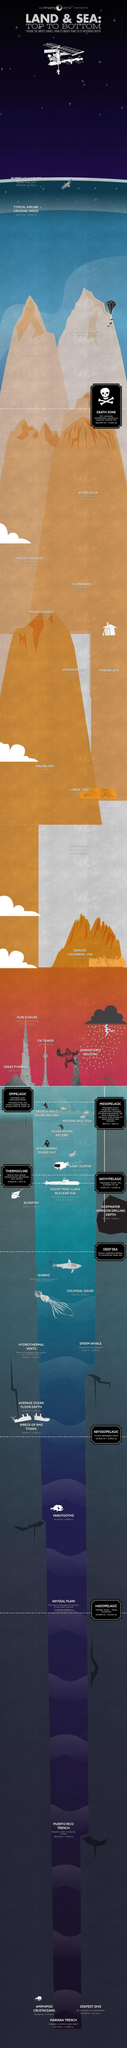Indicate a few pertinent items in this graphic. Vinson Massif is located in Antarctica. The Death Zone is located at an altitude of 26,000 feet, or 7,925 meters. The highest mountain is named Mount Everest. The second highest mountain is named K2. The term 'Death Zone' refers to the point where the pressure of oxygen is insufficient to support human breathing. 